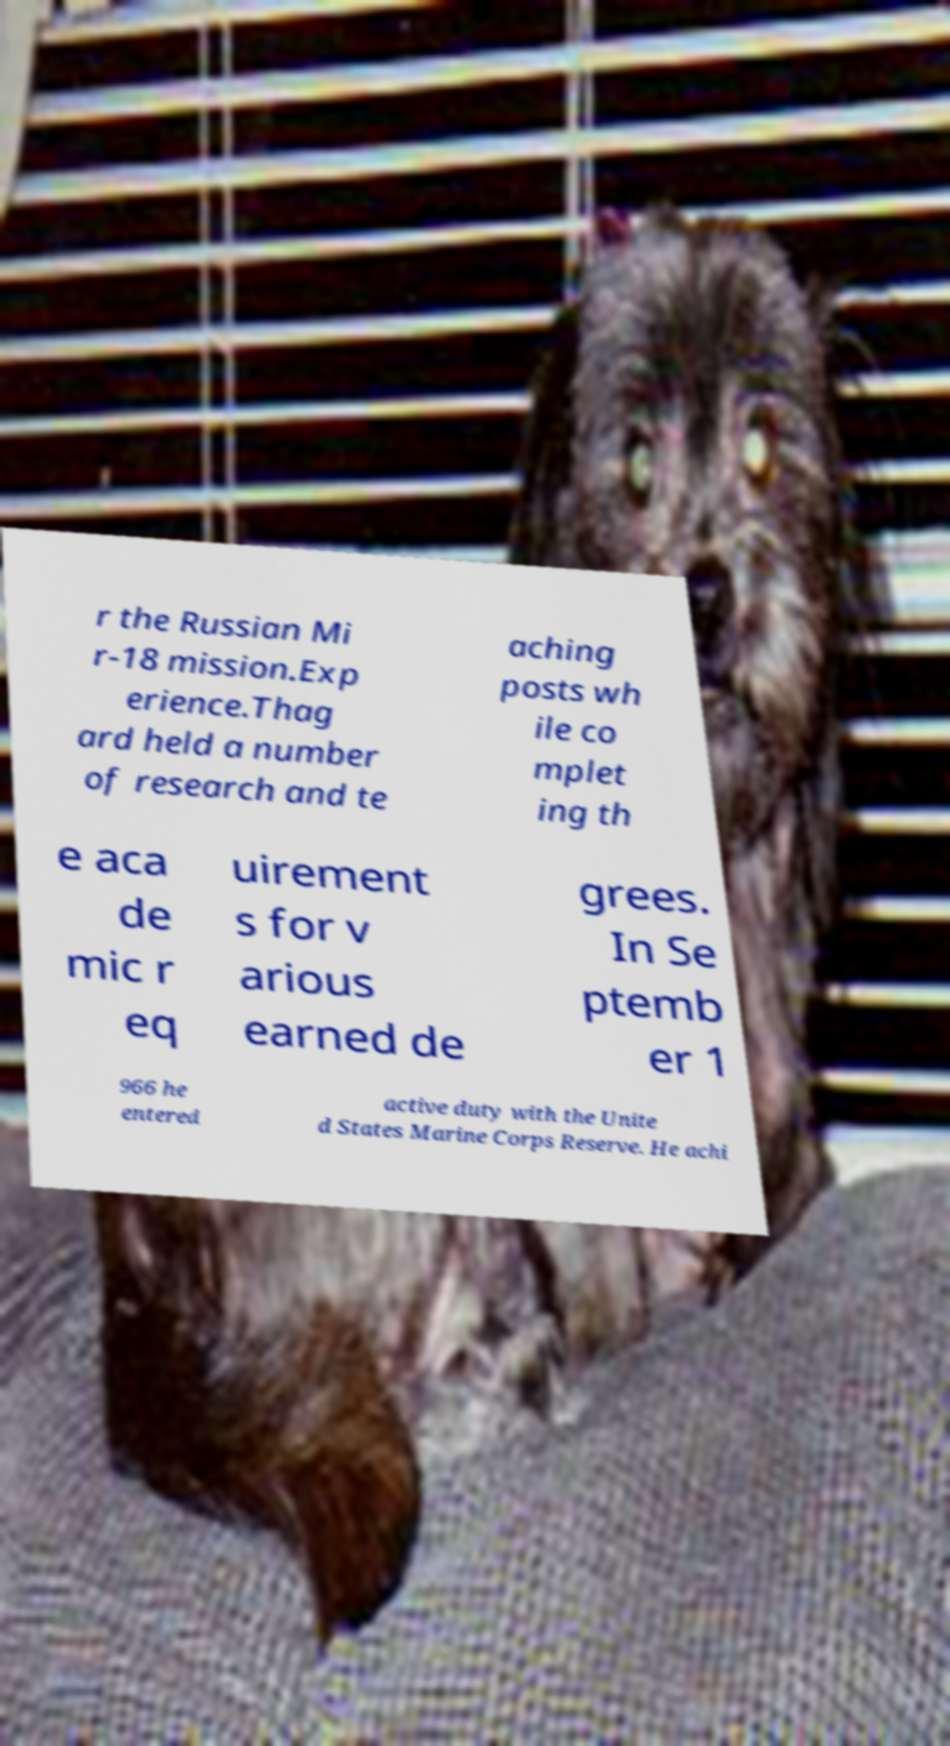Can you read and provide the text displayed in the image?This photo seems to have some interesting text. Can you extract and type it out for me? r the Russian Mi r-18 mission.Exp erience.Thag ard held a number of research and te aching posts wh ile co mplet ing th e aca de mic r eq uirement s for v arious earned de grees. In Se ptemb er 1 966 he entered active duty with the Unite d States Marine Corps Reserve. He achi 